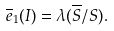Convert formula to latex. <formula><loc_0><loc_0><loc_500><loc_500>\overline { e } _ { 1 } ( I ) = \lambda ( \overline { S } / S ) .</formula> 